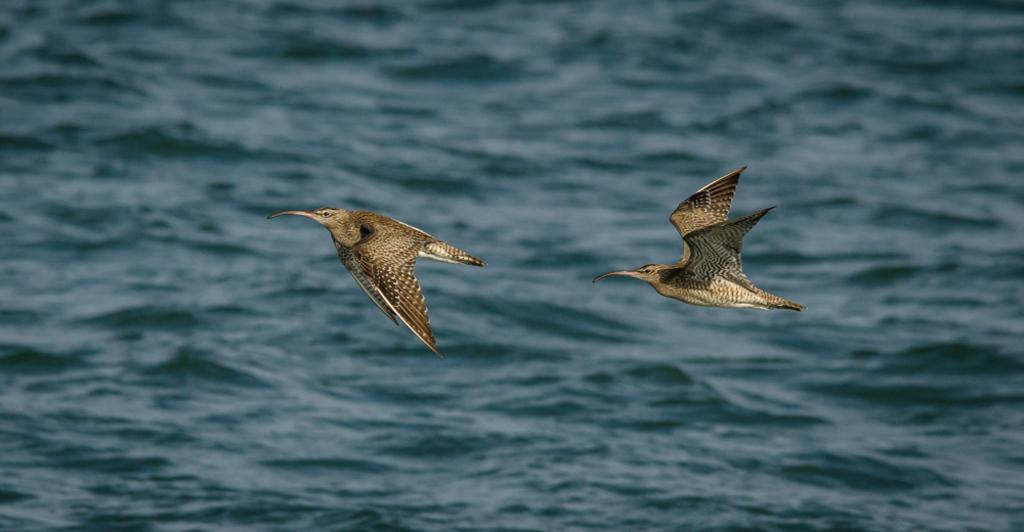What is happening in the sky in the image? There are birds flying in the sky in the image. What can be seen in the background of the image? There is water visible in the background of the image. Where is the map located in the image? There is no map present in the image. What type of river can be seen in the image? There is no river present in the image; only birds flying in the sky and water visible in the background are mentioned. 